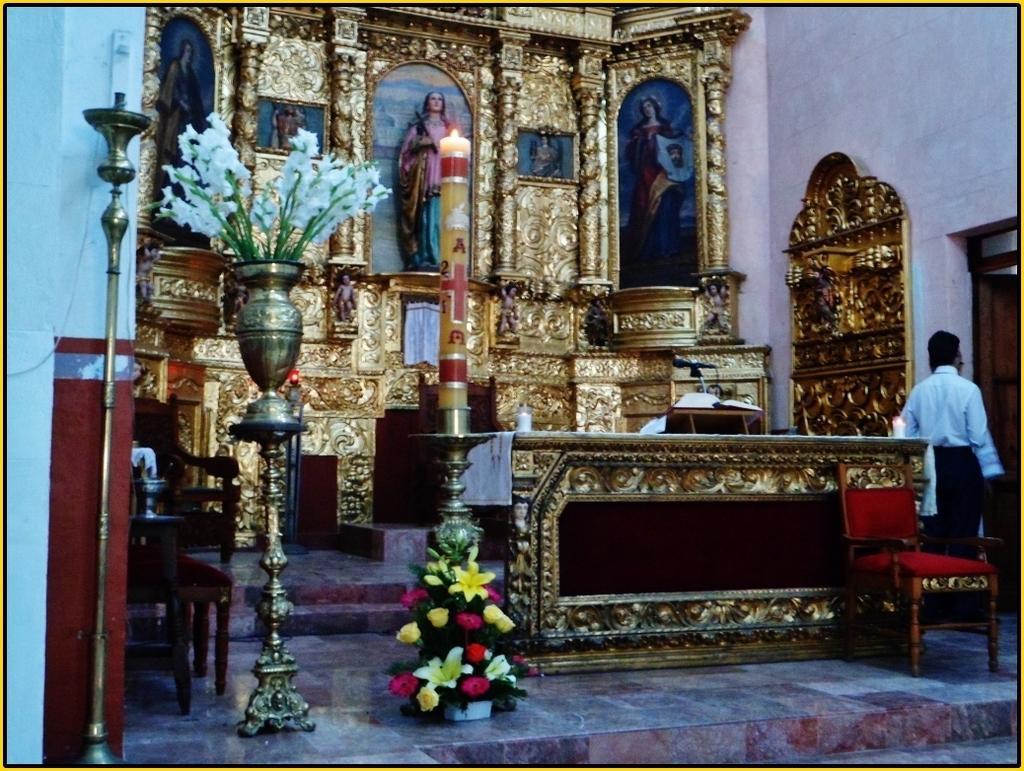Please provide a concise description of this image. In the foreground of this image, there are few flower vases, a candle and few stands. On the left, there is a wall. On the right, there is a chair, desk, book holder, mic and the people on the right side. In the background, there are sculptures and the gold color sculptured wall. 